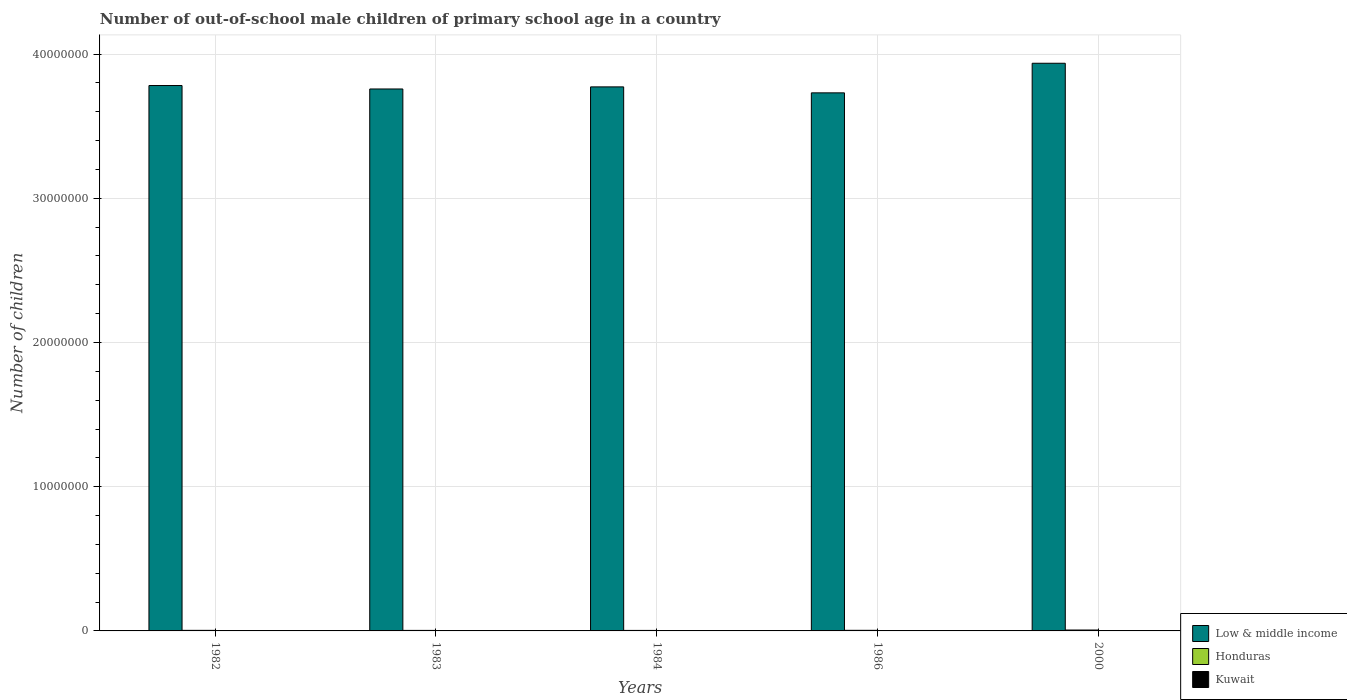How many groups of bars are there?
Your response must be concise. 5. Are the number of bars per tick equal to the number of legend labels?
Offer a very short reply. Yes. What is the label of the 4th group of bars from the left?
Your response must be concise. 1986. What is the number of out-of-school male children in Low & middle income in 1983?
Make the answer very short. 3.76e+07. Across all years, what is the maximum number of out-of-school male children in Kuwait?
Provide a short and direct response. 1.02e+04. Across all years, what is the minimum number of out-of-school male children in Honduras?
Your answer should be very brief. 3.47e+04. In which year was the number of out-of-school male children in Low & middle income maximum?
Make the answer very short. 2000. What is the total number of out-of-school male children in Kuwait in the graph?
Offer a very short reply. 3.63e+04. What is the difference between the number of out-of-school male children in Kuwait in 1984 and that in 2000?
Provide a succinct answer. 1.02e+04. What is the difference between the number of out-of-school male children in Honduras in 2000 and the number of out-of-school male children in Kuwait in 1984?
Your answer should be compact. 5.16e+04. What is the average number of out-of-school male children in Kuwait per year?
Ensure brevity in your answer.  7252. In the year 1982, what is the difference between the number of out-of-school male children in Low & middle income and number of out-of-school male children in Honduras?
Your answer should be very brief. 3.78e+07. In how many years, is the number of out-of-school male children in Low & middle income greater than 18000000?
Keep it short and to the point. 5. What is the ratio of the number of out-of-school male children in Low & middle income in 1984 to that in 1986?
Offer a terse response. 1.01. Is the difference between the number of out-of-school male children in Low & middle income in 1982 and 1983 greater than the difference between the number of out-of-school male children in Honduras in 1982 and 1983?
Keep it short and to the point. Yes. What is the difference between the highest and the second highest number of out-of-school male children in Low & middle income?
Keep it short and to the point. 1.54e+06. What is the difference between the highest and the lowest number of out-of-school male children in Honduras?
Make the answer very short. 2.72e+04. Is the sum of the number of out-of-school male children in Kuwait in 1982 and 2000 greater than the maximum number of out-of-school male children in Honduras across all years?
Give a very brief answer. No. What does the 3rd bar from the left in 1986 represents?
Offer a terse response. Kuwait. What does the 2nd bar from the right in 1986 represents?
Offer a very short reply. Honduras. How many bars are there?
Your answer should be very brief. 15. Are all the bars in the graph horizontal?
Your answer should be very brief. No. Are the values on the major ticks of Y-axis written in scientific E-notation?
Provide a succinct answer. No. Does the graph contain any zero values?
Keep it short and to the point. No. Does the graph contain grids?
Provide a short and direct response. Yes. Where does the legend appear in the graph?
Offer a terse response. Bottom right. What is the title of the graph?
Make the answer very short. Number of out-of-school male children of primary school age in a country. What is the label or title of the Y-axis?
Your response must be concise. Number of children. What is the Number of children in Low & middle income in 1982?
Provide a short and direct response. 3.78e+07. What is the Number of children in Honduras in 1982?
Keep it short and to the point. 3.95e+04. What is the Number of children in Kuwait in 1982?
Give a very brief answer. 7856. What is the Number of children of Low & middle income in 1983?
Provide a succinct answer. 3.76e+07. What is the Number of children in Honduras in 1983?
Provide a succinct answer. 3.67e+04. What is the Number of children of Kuwait in 1983?
Your answer should be compact. 8720. What is the Number of children of Low & middle income in 1984?
Give a very brief answer. 3.77e+07. What is the Number of children of Honduras in 1984?
Keep it short and to the point. 3.47e+04. What is the Number of children of Kuwait in 1984?
Your answer should be compact. 1.02e+04. What is the Number of children of Low & middle income in 1986?
Your response must be concise. 3.73e+07. What is the Number of children in Honduras in 1986?
Ensure brevity in your answer.  4.20e+04. What is the Number of children of Kuwait in 1986?
Your response must be concise. 9352. What is the Number of children in Low & middle income in 2000?
Your response must be concise. 3.94e+07. What is the Number of children in Honduras in 2000?
Provide a short and direct response. 6.19e+04. What is the Number of children of Kuwait in 2000?
Provide a short and direct response. 91. Across all years, what is the maximum Number of children in Low & middle income?
Your response must be concise. 3.94e+07. Across all years, what is the maximum Number of children of Honduras?
Offer a very short reply. 6.19e+04. Across all years, what is the maximum Number of children in Kuwait?
Make the answer very short. 1.02e+04. Across all years, what is the minimum Number of children in Low & middle income?
Keep it short and to the point. 3.73e+07. Across all years, what is the minimum Number of children in Honduras?
Your answer should be very brief. 3.47e+04. Across all years, what is the minimum Number of children of Kuwait?
Your response must be concise. 91. What is the total Number of children in Low & middle income in the graph?
Keep it short and to the point. 1.90e+08. What is the total Number of children in Honduras in the graph?
Give a very brief answer. 2.15e+05. What is the total Number of children in Kuwait in the graph?
Make the answer very short. 3.63e+04. What is the difference between the Number of children in Low & middle income in 1982 and that in 1983?
Make the answer very short. 2.39e+05. What is the difference between the Number of children of Honduras in 1982 and that in 1983?
Provide a succinct answer. 2866. What is the difference between the Number of children of Kuwait in 1982 and that in 1983?
Offer a terse response. -864. What is the difference between the Number of children in Low & middle income in 1982 and that in 1984?
Offer a terse response. 9.41e+04. What is the difference between the Number of children of Honduras in 1982 and that in 1984?
Offer a very short reply. 4840. What is the difference between the Number of children of Kuwait in 1982 and that in 1984?
Provide a short and direct response. -2385. What is the difference between the Number of children in Low & middle income in 1982 and that in 1986?
Your response must be concise. 5.08e+05. What is the difference between the Number of children in Honduras in 1982 and that in 1986?
Your answer should be compact. -2469. What is the difference between the Number of children in Kuwait in 1982 and that in 1986?
Offer a terse response. -1496. What is the difference between the Number of children of Low & middle income in 1982 and that in 2000?
Offer a terse response. -1.54e+06. What is the difference between the Number of children in Honduras in 1982 and that in 2000?
Ensure brevity in your answer.  -2.23e+04. What is the difference between the Number of children in Kuwait in 1982 and that in 2000?
Make the answer very short. 7765. What is the difference between the Number of children in Low & middle income in 1983 and that in 1984?
Provide a succinct answer. -1.45e+05. What is the difference between the Number of children in Honduras in 1983 and that in 1984?
Your answer should be compact. 1974. What is the difference between the Number of children in Kuwait in 1983 and that in 1984?
Your response must be concise. -1521. What is the difference between the Number of children of Low & middle income in 1983 and that in 1986?
Offer a terse response. 2.69e+05. What is the difference between the Number of children in Honduras in 1983 and that in 1986?
Provide a short and direct response. -5335. What is the difference between the Number of children of Kuwait in 1983 and that in 1986?
Provide a short and direct response. -632. What is the difference between the Number of children of Low & middle income in 1983 and that in 2000?
Provide a short and direct response. -1.78e+06. What is the difference between the Number of children in Honduras in 1983 and that in 2000?
Your response must be concise. -2.52e+04. What is the difference between the Number of children in Kuwait in 1983 and that in 2000?
Your answer should be very brief. 8629. What is the difference between the Number of children in Low & middle income in 1984 and that in 1986?
Provide a short and direct response. 4.14e+05. What is the difference between the Number of children of Honduras in 1984 and that in 1986?
Ensure brevity in your answer.  -7309. What is the difference between the Number of children in Kuwait in 1984 and that in 1986?
Offer a very short reply. 889. What is the difference between the Number of children of Low & middle income in 1984 and that in 2000?
Your answer should be compact. -1.64e+06. What is the difference between the Number of children in Honduras in 1984 and that in 2000?
Your answer should be very brief. -2.72e+04. What is the difference between the Number of children of Kuwait in 1984 and that in 2000?
Provide a succinct answer. 1.02e+04. What is the difference between the Number of children of Low & middle income in 1986 and that in 2000?
Offer a very short reply. -2.05e+06. What is the difference between the Number of children in Honduras in 1986 and that in 2000?
Provide a short and direct response. -1.99e+04. What is the difference between the Number of children of Kuwait in 1986 and that in 2000?
Your response must be concise. 9261. What is the difference between the Number of children in Low & middle income in 1982 and the Number of children in Honduras in 1983?
Keep it short and to the point. 3.78e+07. What is the difference between the Number of children in Low & middle income in 1982 and the Number of children in Kuwait in 1983?
Offer a very short reply. 3.78e+07. What is the difference between the Number of children of Honduras in 1982 and the Number of children of Kuwait in 1983?
Ensure brevity in your answer.  3.08e+04. What is the difference between the Number of children in Low & middle income in 1982 and the Number of children in Honduras in 1984?
Offer a very short reply. 3.78e+07. What is the difference between the Number of children in Low & middle income in 1982 and the Number of children in Kuwait in 1984?
Keep it short and to the point. 3.78e+07. What is the difference between the Number of children of Honduras in 1982 and the Number of children of Kuwait in 1984?
Keep it short and to the point. 2.93e+04. What is the difference between the Number of children in Low & middle income in 1982 and the Number of children in Honduras in 1986?
Provide a succinct answer. 3.78e+07. What is the difference between the Number of children of Low & middle income in 1982 and the Number of children of Kuwait in 1986?
Offer a very short reply. 3.78e+07. What is the difference between the Number of children of Honduras in 1982 and the Number of children of Kuwait in 1986?
Your response must be concise. 3.02e+04. What is the difference between the Number of children of Low & middle income in 1982 and the Number of children of Honduras in 2000?
Your response must be concise. 3.78e+07. What is the difference between the Number of children of Low & middle income in 1982 and the Number of children of Kuwait in 2000?
Ensure brevity in your answer.  3.78e+07. What is the difference between the Number of children of Honduras in 1982 and the Number of children of Kuwait in 2000?
Offer a very short reply. 3.95e+04. What is the difference between the Number of children of Low & middle income in 1983 and the Number of children of Honduras in 1984?
Keep it short and to the point. 3.75e+07. What is the difference between the Number of children in Low & middle income in 1983 and the Number of children in Kuwait in 1984?
Provide a short and direct response. 3.76e+07. What is the difference between the Number of children in Honduras in 1983 and the Number of children in Kuwait in 1984?
Provide a short and direct response. 2.64e+04. What is the difference between the Number of children of Low & middle income in 1983 and the Number of children of Honduras in 1986?
Your answer should be compact. 3.75e+07. What is the difference between the Number of children of Low & middle income in 1983 and the Number of children of Kuwait in 1986?
Make the answer very short. 3.76e+07. What is the difference between the Number of children in Honduras in 1983 and the Number of children in Kuwait in 1986?
Keep it short and to the point. 2.73e+04. What is the difference between the Number of children in Low & middle income in 1983 and the Number of children in Honduras in 2000?
Provide a succinct answer. 3.75e+07. What is the difference between the Number of children of Low & middle income in 1983 and the Number of children of Kuwait in 2000?
Your answer should be compact. 3.76e+07. What is the difference between the Number of children of Honduras in 1983 and the Number of children of Kuwait in 2000?
Offer a very short reply. 3.66e+04. What is the difference between the Number of children of Low & middle income in 1984 and the Number of children of Honduras in 1986?
Offer a terse response. 3.77e+07. What is the difference between the Number of children in Low & middle income in 1984 and the Number of children in Kuwait in 1986?
Your answer should be very brief. 3.77e+07. What is the difference between the Number of children in Honduras in 1984 and the Number of children in Kuwait in 1986?
Your answer should be compact. 2.54e+04. What is the difference between the Number of children in Low & middle income in 1984 and the Number of children in Honduras in 2000?
Offer a terse response. 3.77e+07. What is the difference between the Number of children of Low & middle income in 1984 and the Number of children of Kuwait in 2000?
Make the answer very short. 3.77e+07. What is the difference between the Number of children in Honduras in 1984 and the Number of children in Kuwait in 2000?
Make the answer very short. 3.46e+04. What is the difference between the Number of children of Low & middle income in 1986 and the Number of children of Honduras in 2000?
Ensure brevity in your answer.  3.72e+07. What is the difference between the Number of children in Low & middle income in 1986 and the Number of children in Kuwait in 2000?
Provide a succinct answer. 3.73e+07. What is the difference between the Number of children in Honduras in 1986 and the Number of children in Kuwait in 2000?
Provide a succinct answer. 4.19e+04. What is the average Number of children of Low & middle income per year?
Your answer should be compact. 3.80e+07. What is the average Number of children in Honduras per year?
Offer a very short reply. 4.30e+04. What is the average Number of children in Kuwait per year?
Provide a succinct answer. 7252. In the year 1982, what is the difference between the Number of children of Low & middle income and Number of children of Honduras?
Give a very brief answer. 3.78e+07. In the year 1982, what is the difference between the Number of children of Low & middle income and Number of children of Kuwait?
Your answer should be compact. 3.78e+07. In the year 1982, what is the difference between the Number of children in Honduras and Number of children in Kuwait?
Your response must be concise. 3.17e+04. In the year 1983, what is the difference between the Number of children in Low & middle income and Number of children in Honduras?
Your answer should be very brief. 3.75e+07. In the year 1983, what is the difference between the Number of children in Low & middle income and Number of children in Kuwait?
Offer a very short reply. 3.76e+07. In the year 1983, what is the difference between the Number of children of Honduras and Number of children of Kuwait?
Make the answer very short. 2.80e+04. In the year 1984, what is the difference between the Number of children in Low & middle income and Number of children in Honduras?
Offer a terse response. 3.77e+07. In the year 1984, what is the difference between the Number of children in Low & middle income and Number of children in Kuwait?
Offer a very short reply. 3.77e+07. In the year 1984, what is the difference between the Number of children of Honduras and Number of children of Kuwait?
Keep it short and to the point. 2.45e+04. In the year 1986, what is the difference between the Number of children of Low & middle income and Number of children of Honduras?
Provide a succinct answer. 3.73e+07. In the year 1986, what is the difference between the Number of children in Low & middle income and Number of children in Kuwait?
Provide a succinct answer. 3.73e+07. In the year 1986, what is the difference between the Number of children of Honduras and Number of children of Kuwait?
Make the answer very short. 3.27e+04. In the year 2000, what is the difference between the Number of children in Low & middle income and Number of children in Honduras?
Provide a short and direct response. 3.93e+07. In the year 2000, what is the difference between the Number of children of Low & middle income and Number of children of Kuwait?
Ensure brevity in your answer.  3.94e+07. In the year 2000, what is the difference between the Number of children of Honduras and Number of children of Kuwait?
Your response must be concise. 6.18e+04. What is the ratio of the Number of children of Low & middle income in 1982 to that in 1983?
Give a very brief answer. 1.01. What is the ratio of the Number of children of Honduras in 1982 to that in 1983?
Make the answer very short. 1.08. What is the ratio of the Number of children in Kuwait in 1982 to that in 1983?
Make the answer very short. 0.9. What is the ratio of the Number of children of Honduras in 1982 to that in 1984?
Give a very brief answer. 1.14. What is the ratio of the Number of children of Kuwait in 1982 to that in 1984?
Ensure brevity in your answer.  0.77. What is the ratio of the Number of children of Low & middle income in 1982 to that in 1986?
Offer a very short reply. 1.01. What is the ratio of the Number of children of Honduras in 1982 to that in 1986?
Keep it short and to the point. 0.94. What is the ratio of the Number of children of Kuwait in 1982 to that in 1986?
Offer a terse response. 0.84. What is the ratio of the Number of children in Low & middle income in 1982 to that in 2000?
Keep it short and to the point. 0.96. What is the ratio of the Number of children in Honduras in 1982 to that in 2000?
Give a very brief answer. 0.64. What is the ratio of the Number of children in Kuwait in 1982 to that in 2000?
Your response must be concise. 86.33. What is the ratio of the Number of children in Honduras in 1983 to that in 1984?
Offer a very short reply. 1.06. What is the ratio of the Number of children of Kuwait in 1983 to that in 1984?
Provide a succinct answer. 0.85. What is the ratio of the Number of children in Low & middle income in 1983 to that in 1986?
Offer a terse response. 1.01. What is the ratio of the Number of children of Honduras in 1983 to that in 1986?
Provide a short and direct response. 0.87. What is the ratio of the Number of children in Kuwait in 1983 to that in 1986?
Make the answer very short. 0.93. What is the ratio of the Number of children in Low & middle income in 1983 to that in 2000?
Offer a terse response. 0.95. What is the ratio of the Number of children in Honduras in 1983 to that in 2000?
Offer a terse response. 0.59. What is the ratio of the Number of children of Kuwait in 1983 to that in 2000?
Your answer should be very brief. 95.82. What is the ratio of the Number of children of Low & middle income in 1984 to that in 1986?
Your answer should be very brief. 1.01. What is the ratio of the Number of children in Honduras in 1984 to that in 1986?
Offer a very short reply. 0.83. What is the ratio of the Number of children in Kuwait in 1984 to that in 1986?
Provide a short and direct response. 1.1. What is the ratio of the Number of children in Low & middle income in 1984 to that in 2000?
Your response must be concise. 0.96. What is the ratio of the Number of children of Honduras in 1984 to that in 2000?
Offer a very short reply. 0.56. What is the ratio of the Number of children of Kuwait in 1984 to that in 2000?
Give a very brief answer. 112.54. What is the ratio of the Number of children in Low & middle income in 1986 to that in 2000?
Your answer should be compact. 0.95. What is the ratio of the Number of children in Honduras in 1986 to that in 2000?
Provide a short and direct response. 0.68. What is the ratio of the Number of children in Kuwait in 1986 to that in 2000?
Offer a very short reply. 102.77. What is the difference between the highest and the second highest Number of children in Low & middle income?
Give a very brief answer. 1.54e+06. What is the difference between the highest and the second highest Number of children of Honduras?
Provide a short and direct response. 1.99e+04. What is the difference between the highest and the second highest Number of children in Kuwait?
Ensure brevity in your answer.  889. What is the difference between the highest and the lowest Number of children in Low & middle income?
Your response must be concise. 2.05e+06. What is the difference between the highest and the lowest Number of children in Honduras?
Your answer should be compact. 2.72e+04. What is the difference between the highest and the lowest Number of children in Kuwait?
Provide a succinct answer. 1.02e+04. 